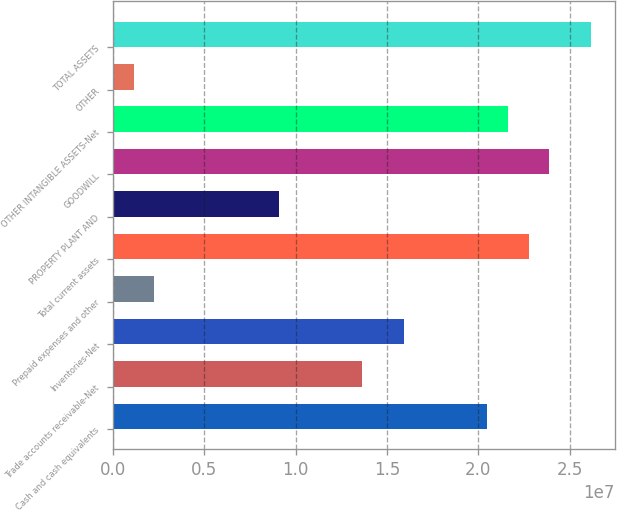Convert chart to OTSL. <chart><loc_0><loc_0><loc_500><loc_500><bar_chart><fcel>Cash and cash equivalents<fcel>Trade accounts receivable-Net<fcel>Inventories-Net<fcel>Prepaid expenses and other<fcel>Total current assets<fcel>PROPERTY PLANT AND<fcel>GOODWILL<fcel>OTHER INTANGIBLE ASSETS-Net<fcel>OTHER<fcel>TOTAL ASSETS<nl><fcel>2.04795e+07<fcel>1.36532e+07<fcel>1.59287e+07<fcel>2.276e+06<fcel>2.2755e+07<fcel>9.10233e+06<fcel>2.38927e+07<fcel>2.16173e+07<fcel>1.13828e+06<fcel>2.61681e+07<nl></chart> 